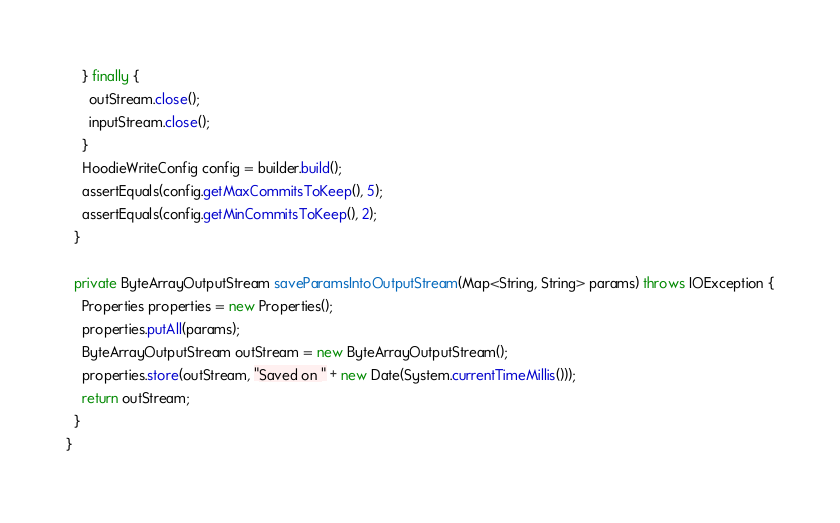<code> <loc_0><loc_0><loc_500><loc_500><_Java_>    } finally {
      outStream.close();
      inputStream.close();
    }
    HoodieWriteConfig config = builder.build();
    assertEquals(config.getMaxCommitsToKeep(), 5);
    assertEquals(config.getMinCommitsToKeep(), 2);
  }

  private ByteArrayOutputStream saveParamsIntoOutputStream(Map<String, String> params) throws IOException {
    Properties properties = new Properties();
    properties.putAll(params);
    ByteArrayOutputStream outStream = new ByteArrayOutputStream();
    properties.store(outStream, "Saved on " + new Date(System.currentTimeMillis()));
    return outStream;
  }
}
</code> 